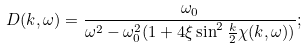<formula> <loc_0><loc_0><loc_500><loc_500>D ( k , \omega ) = \frac { \omega _ { 0 } } { \omega ^ { 2 } - \omega _ { 0 } ^ { 2 } ( 1 + 4 \xi \sin ^ { 2 } \frac { k } { 2 } \chi ( k , \omega ) ) } ;</formula> 